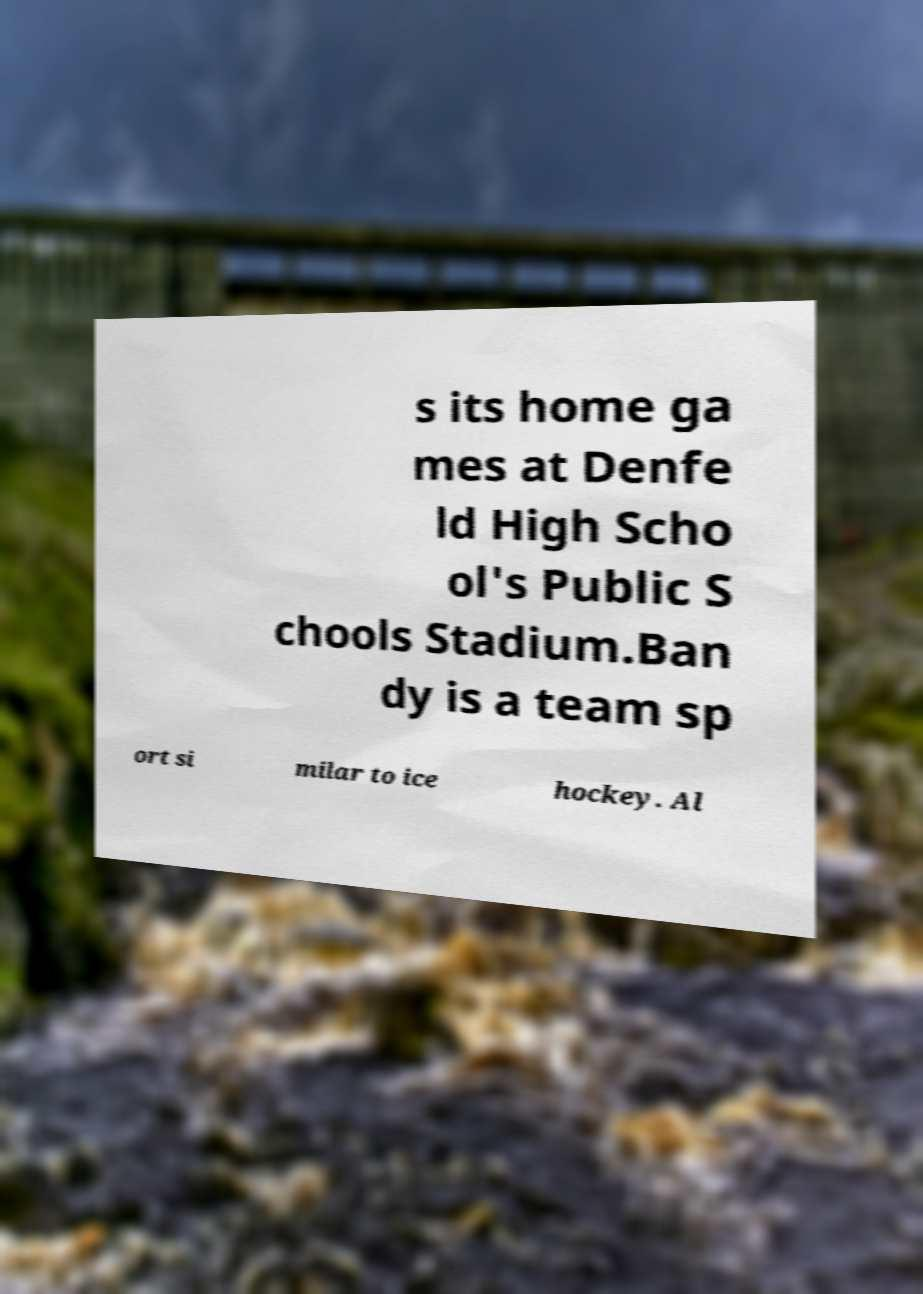Can you accurately transcribe the text from the provided image for me? s its home ga mes at Denfe ld High Scho ol's Public S chools Stadium.Ban dy is a team sp ort si milar to ice hockey. Al 